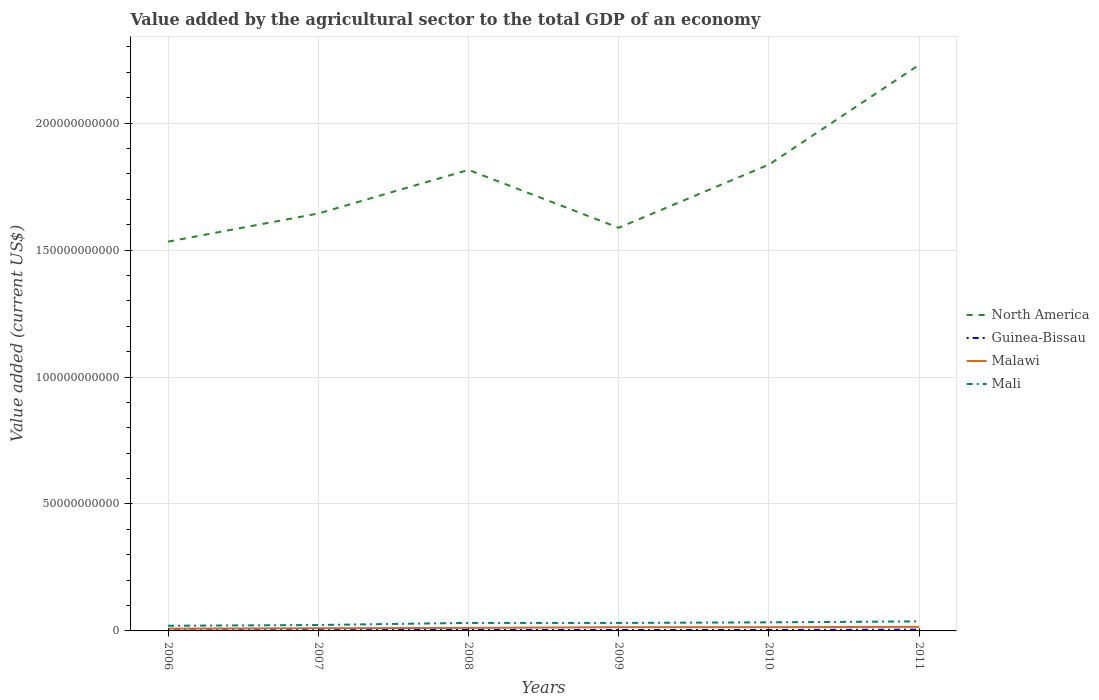Across all years, what is the maximum value added by the agricultural sector to the total GDP in Malawi?
Give a very brief answer. 8.95e+08. What is the total value added by the agricultural sector to the total GDP in North America in the graph?
Your response must be concise. -2.08e+09. What is the difference between the highest and the second highest value added by the agricultural sector to the total GDP in Mali?
Your response must be concise. 1.72e+09. What is the difference between the highest and the lowest value added by the agricultural sector to the total GDP in North America?
Offer a very short reply. 3. Is the value added by the agricultural sector to the total GDP in Malawi strictly greater than the value added by the agricultural sector to the total GDP in Mali over the years?
Your response must be concise. Yes. How many lines are there?
Provide a short and direct response. 4. What is the difference between two consecutive major ticks on the Y-axis?
Provide a short and direct response. 5.00e+1. Are the values on the major ticks of Y-axis written in scientific E-notation?
Your answer should be compact. No. Does the graph contain any zero values?
Make the answer very short. No. Does the graph contain grids?
Give a very brief answer. Yes. Where does the legend appear in the graph?
Ensure brevity in your answer.  Center right. How are the legend labels stacked?
Your answer should be very brief. Vertical. What is the title of the graph?
Offer a terse response. Value added by the agricultural sector to the total GDP of an economy. What is the label or title of the Y-axis?
Ensure brevity in your answer.  Value added (current US$). What is the Value added (current US$) of North America in 2006?
Your answer should be compact. 1.53e+11. What is the Value added (current US$) of Guinea-Bissau in 2006?
Offer a very short reply. 2.48e+08. What is the Value added (current US$) in Malawi in 2006?
Provide a short and direct response. 8.95e+08. What is the Value added (current US$) in Mali in 2006?
Offer a terse response. 2.03e+09. What is the Value added (current US$) in North America in 2007?
Provide a short and direct response. 1.64e+11. What is the Value added (current US$) in Guinea-Bissau in 2007?
Provide a short and direct response. 2.98e+08. What is the Value added (current US$) in Malawi in 2007?
Your response must be concise. 1.06e+09. What is the Value added (current US$) in Mali in 2007?
Make the answer very short. 2.33e+09. What is the Value added (current US$) in North America in 2008?
Your answer should be very brief. 1.82e+11. What is the Value added (current US$) in Guinea-Bissau in 2008?
Give a very brief answer. 4.01e+08. What is the Value added (current US$) of Malawi in 2008?
Your response must be concise. 1.19e+09. What is the Value added (current US$) of Mali in 2008?
Offer a very short reply. 3.15e+09. What is the Value added (current US$) of North America in 2009?
Your answer should be compact. 1.59e+11. What is the Value added (current US$) in Guinea-Bissau in 2009?
Make the answer very short. 3.61e+08. What is the Value added (current US$) in Malawi in 2009?
Keep it short and to the point. 1.47e+09. What is the Value added (current US$) of Mali in 2009?
Your answer should be compact. 3.15e+09. What is the Value added (current US$) of North America in 2010?
Your response must be concise. 1.84e+11. What is the Value added (current US$) in Guinea-Bissau in 2010?
Make the answer very short. 3.80e+08. What is the Value added (current US$) of Malawi in 2010?
Keep it short and to the point. 1.48e+09. What is the Value added (current US$) of Mali in 2010?
Provide a succinct answer. 3.38e+09. What is the Value added (current US$) in North America in 2011?
Keep it short and to the point. 2.23e+11. What is the Value added (current US$) in Guinea-Bissau in 2011?
Provide a succinct answer. 4.91e+08. What is the Value added (current US$) in Malawi in 2011?
Your answer should be compact. 1.60e+09. What is the Value added (current US$) in Mali in 2011?
Offer a terse response. 3.76e+09. Across all years, what is the maximum Value added (current US$) in North America?
Provide a short and direct response. 2.23e+11. Across all years, what is the maximum Value added (current US$) of Guinea-Bissau?
Offer a very short reply. 4.91e+08. Across all years, what is the maximum Value added (current US$) of Malawi?
Your answer should be very brief. 1.60e+09. Across all years, what is the maximum Value added (current US$) in Mali?
Provide a succinct answer. 3.76e+09. Across all years, what is the minimum Value added (current US$) of North America?
Offer a very short reply. 1.53e+11. Across all years, what is the minimum Value added (current US$) in Guinea-Bissau?
Offer a very short reply. 2.48e+08. Across all years, what is the minimum Value added (current US$) of Malawi?
Your answer should be very brief. 8.95e+08. Across all years, what is the minimum Value added (current US$) in Mali?
Your answer should be compact. 2.03e+09. What is the total Value added (current US$) of North America in the graph?
Provide a succinct answer. 1.06e+12. What is the total Value added (current US$) of Guinea-Bissau in the graph?
Ensure brevity in your answer.  2.18e+09. What is the total Value added (current US$) in Malawi in the graph?
Your answer should be very brief. 7.70e+09. What is the total Value added (current US$) of Mali in the graph?
Your response must be concise. 1.78e+1. What is the difference between the Value added (current US$) of North America in 2006 and that in 2007?
Your response must be concise. -1.11e+1. What is the difference between the Value added (current US$) in Guinea-Bissau in 2006 and that in 2007?
Keep it short and to the point. -5.02e+07. What is the difference between the Value added (current US$) in Malawi in 2006 and that in 2007?
Provide a succinct answer. -1.62e+08. What is the difference between the Value added (current US$) of Mali in 2006 and that in 2007?
Give a very brief answer. -2.92e+08. What is the difference between the Value added (current US$) in North America in 2006 and that in 2008?
Your response must be concise. -2.82e+1. What is the difference between the Value added (current US$) of Guinea-Bissau in 2006 and that in 2008?
Your answer should be compact. -1.53e+08. What is the difference between the Value added (current US$) in Malawi in 2006 and that in 2008?
Offer a very short reply. -2.99e+08. What is the difference between the Value added (current US$) in Mali in 2006 and that in 2008?
Offer a terse response. -1.12e+09. What is the difference between the Value added (current US$) of North America in 2006 and that in 2009?
Keep it short and to the point. -5.45e+09. What is the difference between the Value added (current US$) of Guinea-Bissau in 2006 and that in 2009?
Your answer should be very brief. -1.13e+08. What is the difference between the Value added (current US$) in Malawi in 2006 and that in 2009?
Your answer should be very brief. -5.74e+08. What is the difference between the Value added (current US$) of Mali in 2006 and that in 2009?
Your answer should be very brief. -1.11e+09. What is the difference between the Value added (current US$) in North America in 2006 and that in 2010?
Offer a very short reply. -3.03e+1. What is the difference between the Value added (current US$) in Guinea-Bissau in 2006 and that in 2010?
Your answer should be very brief. -1.32e+08. What is the difference between the Value added (current US$) in Malawi in 2006 and that in 2010?
Your response must be concise. -5.88e+08. What is the difference between the Value added (current US$) in Mali in 2006 and that in 2010?
Offer a terse response. -1.34e+09. What is the difference between the Value added (current US$) of North America in 2006 and that in 2011?
Your answer should be very brief. -6.96e+1. What is the difference between the Value added (current US$) in Guinea-Bissau in 2006 and that in 2011?
Your answer should be very brief. -2.43e+08. What is the difference between the Value added (current US$) in Malawi in 2006 and that in 2011?
Give a very brief answer. -7.08e+08. What is the difference between the Value added (current US$) in Mali in 2006 and that in 2011?
Give a very brief answer. -1.72e+09. What is the difference between the Value added (current US$) in North America in 2007 and that in 2008?
Your response must be concise. -1.72e+1. What is the difference between the Value added (current US$) of Guinea-Bissau in 2007 and that in 2008?
Keep it short and to the point. -1.02e+08. What is the difference between the Value added (current US$) in Malawi in 2007 and that in 2008?
Ensure brevity in your answer.  -1.37e+08. What is the difference between the Value added (current US$) of Mali in 2007 and that in 2008?
Offer a very short reply. -8.28e+08. What is the difference between the Value added (current US$) in North America in 2007 and that in 2009?
Offer a terse response. 5.62e+09. What is the difference between the Value added (current US$) in Guinea-Bissau in 2007 and that in 2009?
Your response must be concise. -6.27e+07. What is the difference between the Value added (current US$) in Malawi in 2007 and that in 2009?
Provide a short and direct response. -4.12e+08. What is the difference between the Value added (current US$) of Mali in 2007 and that in 2009?
Offer a very short reply. -8.22e+08. What is the difference between the Value added (current US$) in North America in 2007 and that in 2010?
Provide a succinct answer. -1.93e+1. What is the difference between the Value added (current US$) in Guinea-Bissau in 2007 and that in 2010?
Your answer should be compact. -8.20e+07. What is the difference between the Value added (current US$) in Malawi in 2007 and that in 2010?
Offer a very short reply. -4.26e+08. What is the difference between the Value added (current US$) of Mali in 2007 and that in 2010?
Offer a terse response. -1.05e+09. What is the difference between the Value added (current US$) in North America in 2007 and that in 2011?
Offer a terse response. -5.85e+1. What is the difference between the Value added (current US$) of Guinea-Bissau in 2007 and that in 2011?
Provide a succinct answer. -1.93e+08. What is the difference between the Value added (current US$) in Malawi in 2007 and that in 2011?
Provide a succinct answer. -5.46e+08. What is the difference between the Value added (current US$) of Mali in 2007 and that in 2011?
Your answer should be very brief. -1.43e+09. What is the difference between the Value added (current US$) in North America in 2008 and that in 2009?
Ensure brevity in your answer.  2.28e+1. What is the difference between the Value added (current US$) of Guinea-Bissau in 2008 and that in 2009?
Your answer should be compact. 3.97e+07. What is the difference between the Value added (current US$) of Malawi in 2008 and that in 2009?
Offer a very short reply. -2.75e+08. What is the difference between the Value added (current US$) of Mali in 2008 and that in 2009?
Keep it short and to the point. 5.58e+06. What is the difference between the Value added (current US$) in North America in 2008 and that in 2010?
Provide a short and direct response. -2.08e+09. What is the difference between the Value added (current US$) of Guinea-Bissau in 2008 and that in 2010?
Provide a short and direct response. 2.05e+07. What is the difference between the Value added (current US$) in Malawi in 2008 and that in 2010?
Your answer should be compact. -2.88e+08. What is the difference between the Value added (current US$) in Mali in 2008 and that in 2010?
Offer a terse response. -2.24e+08. What is the difference between the Value added (current US$) in North America in 2008 and that in 2011?
Your answer should be very brief. -4.14e+1. What is the difference between the Value added (current US$) of Guinea-Bissau in 2008 and that in 2011?
Provide a succinct answer. -9.05e+07. What is the difference between the Value added (current US$) in Malawi in 2008 and that in 2011?
Offer a very short reply. -4.09e+08. What is the difference between the Value added (current US$) in Mali in 2008 and that in 2011?
Give a very brief answer. -6.04e+08. What is the difference between the Value added (current US$) of North America in 2009 and that in 2010?
Keep it short and to the point. -2.49e+1. What is the difference between the Value added (current US$) in Guinea-Bissau in 2009 and that in 2010?
Ensure brevity in your answer.  -1.93e+07. What is the difference between the Value added (current US$) of Malawi in 2009 and that in 2010?
Offer a terse response. -1.34e+07. What is the difference between the Value added (current US$) of Mali in 2009 and that in 2010?
Your answer should be very brief. -2.30e+08. What is the difference between the Value added (current US$) in North America in 2009 and that in 2011?
Ensure brevity in your answer.  -6.42e+1. What is the difference between the Value added (current US$) of Guinea-Bissau in 2009 and that in 2011?
Your answer should be compact. -1.30e+08. What is the difference between the Value added (current US$) of Malawi in 2009 and that in 2011?
Make the answer very short. -1.34e+08. What is the difference between the Value added (current US$) in Mali in 2009 and that in 2011?
Offer a terse response. -6.10e+08. What is the difference between the Value added (current US$) in North America in 2010 and that in 2011?
Give a very brief answer. -3.93e+1. What is the difference between the Value added (current US$) of Guinea-Bissau in 2010 and that in 2011?
Ensure brevity in your answer.  -1.11e+08. What is the difference between the Value added (current US$) of Malawi in 2010 and that in 2011?
Give a very brief answer. -1.20e+08. What is the difference between the Value added (current US$) of Mali in 2010 and that in 2011?
Your answer should be very brief. -3.80e+08. What is the difference between the Value added (current US$) in North America in 2006 and the Value added (current US$) in Guinea-Bissau in 2007?
Your answer should be compact. 1.53e+11. What is the difference between the Value added (current US$) of North America in 2006 and the Value added (current US$) of Malawi in 2007?
Offer a terse response. 1.52e+11. What is the difference between the Value added (current US$) in North America in 2006 and the Value added (current US$) in Mali in 2007?
Provide a succinct answer. 1.51e+11. What is the difference between the Value added (current US$) in Guinea-Bissau in 2006 and the Value added (current US$) in Malawi in 2007?
Your answer should be compact. -8.09e+08. What is the difference between the Value added (current US$) of Guinea-Bissau in 2006 and the Value added (current US$) of Mali in 2007?
Give a very brief answer. -2.08e+09. What is the difference between the Value added (current US$) in Malawi in 2006 and the Value added (current US$) in Mali in 2007?
Your answer should be very brief. -1.43e+09. What is the difference between the Value added (current US$) in North America in 2006 and the Value added (current US$) in Guinea-Bissau in 2008?
Offer a terse response. 1.53e+11. What is the difference between the Value added (current US$) in North America in 2006 and the Value added (current US$) in Malawi in 2008?
Give a very brief answer. 1.52e+11. What is the difference between the Value added (current US$) in North America in 2006 and the Value added (current US$) in Mali in 2008?
Offer a terse response. 1.50e+11. What is the difference between the Value added (current US$) of Guinea-Bissau in 2006 and the Value added (current US$) of Malawi in 2008?
Provide a succinct answer. -9.47e+08. What is the difference between the Value added (current US$) in Guinea-Bissau in 2006 and the Value added (current US$) in Mali in 2008?
Give a very brief answer. -2.91e+09. What is the difference between the Value added (current US$) in Malawi in 2006 and the Value added (current US$) in Mali in 2008?
Provide a succinct answer. -2.26e+09. What is the difference between the Value added (current US$) in North America in 2006 and the Value added (current US$) in Guinea-Bissau in 2009?
Offer a terse response. 1.53e+11. What is the difference between the Value added (current US$) of North America in 2006 and the Value added (current US$) of Malawi in 2009?
Make the answer very short. 1.52e+11. What is the difference between the Value added (current US$) in North America in 2006 and the Value added (current US$) in Mali in 2009?
Give a very brief answer. 1.50e+11. What is the difference between the Value added (current US$) in Guinea-Bissau in 2006 and the Value added (current US$) in Malawi in 2009?
Provide a succinct answer. -1.22e+09. What is the difference between the Value added (current US$) in Guinea-Bissau in 2006 and the Value added (current US$) in Mali in 2009?
Offer a very short reply. -2.90e+09. What is the difference between the Value added (current US$) in Malawi in 2006 and the Value added (current US$) in Mali in 2009?
Keep it short and to the point. -2.25e+09. What is the difference between the Value added (current US$) of North America in 2006 and the Value added (current US$) of Guinea-Bissau in 2010?
Offer a terse response. 1.53e+11. What is the difference between the Value added (current US$) of North America in 2006 and the Value added (current US$) of Malawi in 2010?
Make the answer very short. 1.52e+11. What is the difference between the Value added (current US$) of North America in 2006 and the Value added (current US$) of Mali in 2010?
Your response must be concise. 1.50e+11. What is the difference between the Value added (current US$) in Guinea-Bissau in 2006 and the Value added (current US$) in Malawi in 2010?
Your answer should be compact. -1.24e+09. What is the difference between the Value added (current US$) in Guinea-Bissau in 2006 and the Value added (current US$) in Mali in 2010?
Your answer should be compact. -3.13e+09. What is the difference between the Value added (current US$) of Malawi in 2006 and the Value added (current US$) of Mali in 2010?
Keep it short and to the point. -2.48e+09. What is the difference between the Value added (current US$) in North America in 2006 and the Value added (current US$) in Guinea-Bissau in 2011?
Provide a succinct answer. 1.53e+11. What is the difference between the Value added (current US$) in North America in 2006 and the Value added (current US$) in Malawi in 2011?
Provide a short and direct response. 1.52e+11. What is the difference between the Value added (current US$) of North America in 2006 and the Value added (current US$) of Mali in 2011?
Provide a succinct answer. 1.50e+11. What is the difference between the Value added (current US$) of Guinea-Bissau in 2006 and the Value added (current US$) of Malawi in 2011?
Make the answer very short. -1.36e+09. What is the difference between the Value added (current US$) in Guinea-Bissau in 2006 and the Value added (current US$) in Mali in 2011?
Provide a short and direct response. -3.51e+09. What is the difference between the Value added (current US$) in Malawi in 2006 and the Value added (current US$) in Mali in 2011?
Offer a very short reply. -2.86e+09. What is the difference between the Value added (current US$) of North America in 2007 and the Value added (current US$) of Guinea-Bissau in 2008?
Ensure brevity in your answer.  1.64e+11. What is the difference between the Value added (current US$) in North America in 2007 and the Value added (current US$) in Malawi in 2008?
Offer a very short reply. 1.63e+11. What is the difference between the Value added (current US$) of North America in 2007 and the Value added (current US$) of Mali in 2008?
Ensure brevity in your answer.  1.61e+11. What is the difference between the Value added (current US$) of Guinea-Bissau in 2007 and the Value added (current US$) of Malawi in 2008?
Offer a very short reply. -8.96e+08. What is the difference between the Value added (current US$) of Guinea-Bissau in 2007 and the Value added (current US$) of Mali in 2008?
Offer a very short reply. -2.86e+09. What is the difference between the Value added (current US$) of Malawi in 2007 and the Value added (current US$) of Mali in 2008?
Ensure brevity in your answer.  -2.10e+09. What is the difference between the Value added (current US$) of North America in 2007 and the Value added (current US$) of Guinea-Bissau in 2009?
Offer a very short reply. 1.64e+11. What is the difference between the Value added (current US$) of North America in 2007 and the Value added (current US$) of Malawi in 2009?
Provide a short and direct response. 1.63e+11. What is the difference between the Value added (current US$) of North America in 2007 and the Value added (current US$) of Mali in 2009?
Provide a succinct answer. 1.61e+11. What is the difference between the Value added (current US$) of Guinea-Bissau in 2007 and the Value added (current US$) of Malawi in 2009?
Offer a very short reply. -1.17e+09. What is the difference between the Value added (current US$) of Guinea-Bissau in 2007 and the Value added (current US$) of Mali in 2009?
Provide a succinct answer. -2.85e+09. What is the difference between the Value added (current US$) in Malawi in 2007 and the Value added (current US$) in Mali in 2009?
Your response must be concise. -2.09e+09. What is the difference between the Value added (current US$) of North America in 2007 and the Value added (current US$) of Guinea-Bissau in 2010?
Provide a short and direct response. 1.64e+11. What is the difference between the Value added (current US$) in North America in 2007 and the Value added (current US$) in Malawi in 2010?
Your response must be concise. 1.63e+11. What is the difference between the Value added (current US$) of North America in 2007 and the Value added (current US$) of Mali in 2010?
Your answer should be compact. 1.61e+11. What is the difference between the Value added (current US$) in Guinea-Bissau in 2007 and the Value added (current US$) in Malawi in 2010?
Your response must be concise. -1.18e+09. What is the difference between the Value added (current US$) of Guinea-Bissau in 2007 and the Value added (current US$) of Mali in 2010?
Offer a very short reply. -3.08e+09. What is the difference between the Value added (current US$) in Malawi in 2007 and the Value added (current US$) in Mali in 2010?
Your response must be concise. -2.32e+09. What is the difference between the Value added (current US$) of North America in 2007 and the Value added (current US$) of Guinea-Bissau in 2011?
Your response must be concise. 1.64e+11. What is the difference between the Value added (current US$) in North America in 2007 and the Value added (current US$) in Malawi in 2011?
Provide a short and direct response. 1.63e+11. What is the difference between the Value added (current US$) in North America in 2007 and the Value added (current US$) in Mali in 2011?
Your answer should be very brief. 1.61e+11. What is the difference between the Value added (current US$) in Guinea-Bissau in 2007 and the Value added (current US$) in Malawi in 2011?
Offer a terse response. -1.31e+09. What is the difference between the Value added (current US$) of Guinea-Bissau in 2007 and the Value added (current US$) of Mali in 2011?
Offer a very short reply. -3.46e+09. What is the difference between the Value added (current US$) of Malawi in 2007 and the Value added (current US$) of Mali in 2011?
Your answer should be compact. -2.70e+09. What is the difference between the Value added (current US$) in North America in 2008 and the Value added (current US$) in Guinea-Bissau in 2009?
Offer a very short reply. 1.81e+11. What is the difference between the Value added (current US$) in North America in 2008 and the Value added (current US$) in Malawi in 2009?
Provide a short and direct response. 1.80e+11. What is the difference between the Value added (current US$) of North America in 2008 and the Value added (current US$) of Mali in 2009?
Make the answer very short. 1.78e+11. What is the difference between the Value added (current US$) of Guinea-Bissau in 2008 and the Value added (current US$) of Malawi in 2009?
Your answer should be very brief. -1.07e+09. What is the difference between the Value added (current US$) in Guinea-Bissau in 2008 and the Value added (current US$) in Mali in 2009?
Provide a short and direct response. -2.75e+09. What is the difference between the Value added (current US$) of Malawi in 2008 and the Value added (current US$) of Mali in 2009?
Keep it short and to the point. -1.95e+09. What is the difference between the Value added (current US$) of North America in 2008 and the Value added (current US$) of Guinea-Bissau in 2010?
Offer a terse response. 1.81e+11. What is the difference between the Value added (current US$) of North America in 2008 and the Value added (current US$) of Malawi in 2010?
Your response must be concise. 1.80e+11. What is the difference between the Value added (current US$) of North America in 2008 and the Value added (current US$) of Mali in 2010?
Provide a succinct answer. 1.78e+11. What is the difference between the Value added (current US$) of Guinea-Bissau in 2008 and the Value added (current US$) of Malawi in 2010?
Your answer should be very brief. -1.08e+09. What is the difference between the Value added (current US$) in Guinea-Bissau in 2008 and the Value added (current US$) in Mali in 2010?
Make the answer very short. -2.98e+09. What is the difference between the Value added (current US$) of Malawi in 2008 and the Value added (current US$) of Mali in 2010?
Give a very brief answer. -2.18e+09. What is the difference between the Value added (current US$) in North America in 2008 and the Value added (current US$) in Guinea-Bissau in 2011?
Keep it short and to the point. 1.81e+11. What is the difference between the Value added (current US$) of North America in 2008 and the Value added (current US$) of Malawi in 2011?
Offer a terse response. 1.80e+11. What is the difference between the Value added (current US$) in North America in 2008 and the Value added (current US$) in Mali in 2011?
Your answer should be very brief. 1.78e+11. What is the difference between the Value added (current US$) in Guinea-Bissau in 2008 and the Value added (current US$) in Malawi in 2011?
Make the answer very short. -1.20e+09. What is the difference between the Value added (current US$) of Guinea-Bissau in 2008 and the Value added (current US$) of Mali in 2011?
Keep it short and to the point. -3.36e+09. What is the difference between the Value added (current US$) of Malawi in 2008 and the Value added (current US$) of Mali in 2011?
Your answer should be very brief. -2.56e+09. What is the difference between the Value added (current US$) of North America in 2009 and the Value added (current US$) of Guinea-Bissau in 2010?
Offer a very short reply. 1.58e+11. What is the difference between the Value added (current US$) of North America in 2009 and the Value added (current US$) of Malawi in 2010?
Your answer should be very brief. 1.57e+11. What is the difference between the Value added (current US$) of North America in 2009 and the Value added (current US$) of Mali in 2010?
Keep it short and to the point. 1.55e+11. What is the difference between the Value added (current US$) of Guinea-Bissau in 2009 and the Value added (current US$) of Malawi in 2010?
Keep it short and to the point. -1.12e+09. What is the difference between the Value added (current US$) of Guinea-Bissau in 2009 and the Value added (current US$) of Mali in 2010?
Your answer should be very brief. -3.02e+09. What is the difference between the Value added (current US$) in Malawi in 2009 and the Value added (current US$) in Mali in 2010?
Make the answer very short. -1.91e+09. What is the difference between the Value added (current US$) in North America in 2009 and the Value added (current US$) in Guinea-Bissau in 2011?
Your response must be concise. 1.58e+11. What is the difference between the Value added (current US$) of North America in 2009 and the Value added (current US$) of Malawi in 2011?
Your response must be concise. 1.57e+11. What is the difference between the Value added (current US$) in North America in 2009 and the Value added (current US$) in Mali in 2011?
Keep it short and to the point. 1.55e+11. What is the difference between the Value added (current US$) of Guinea-Bissau in 2009 and the Value added (current US$) of Malawi in 2011?
Make the answer very short. -1.24e+09. What is the difference between the Value added (current US$) of Guinea-Bissau in 2009 and the Value added (current US$) of Mali in 2011?
Offer a very short reply. -3.40e+09. What is the difference between the Value added (current US$) of Malawi in 2009 and the Value added (current US$) of Mali in 2011?
Ensure brevity in your answer.  -2.29e+09. What is the difference between the Value added (current US$) in North America in 2010 and the Value added (current US$) in Guinea-Bissau in 2011?
Provide a short and direct response. 1.83e+11. What is the difference between the Value added (current US$) in North America in 2010 and the Value added (current US$) in Malawi in 2011?
Provide a short and direct response. 1.82e+11. What is the difference between the Value added (current US$) of North America in 2010 and the Value added (current US$) of Mali in 2011?
Provide a short and direct response. 1.80e+11. What is the difference between the Value added (current US$) in Guinea-Bissau in 2010 and the Value added (current US$) in Malawi in 2011?
Give a very brief answer. -1.22e+09. What is the difference between the Value added (current US$) in Guinea-Bissau in 2010 and the Value added (current US$) in Mali in 2011?
Give a very brief answer. -3.38e+09. What is the difference between the Value added (current US$) of Malawi in 2010 and the Value added (current US$) of Mali in 2011?
Your answer should be very brief. -2.27e+09. What is the average Value added (current US$) of North America per year?
Your response must be concise. 1.77e+11. What is the average Value added (current US$) in Guinea-Bissau per year?
Your response must be concise. 3.63e+08. What is the average Value added (current US$) of Malawi per year?
Your answer should be compact. 1.28e+09. What is the average Value added (current US$) in Mali per year?
Your answer should be very brief. 2.97e+09. In the year 2006, what is the difference between the Value added (current US$) in North America and Value added (current US$) in Guinea-Bissau?
Provide a succinct answer. 1.53e+11. In the year 2006, what is the difference between the Value added (current US$) in North America and Value added (current US$) in Malawi?
Your answer should be very brief. 1.52e+11. In the year 2006, what is the difference between the Value added (current US$) in North America and Value added (current US$) in Mali?
Offer a very short reply. 1.51e+11. In the year 2006, what is the difference between the Value added (current US$) in Guinea-Bissau and Value added (current US$) in Malawi?
Give a very brief answer. -6.47e+08. In the year 2006, what is the difference between the Value added (current US$) in Guinea-Bissau and Value added (current US$) in Mali?
Offer a very short reply. -1.79e+09. In the year 2006, what is the difference between the Value added (current US$) in Malawi and Value added (current US$) in Mali?
Your answer should be compact. -1.14e+09. In the year 2007, what is the difference between the Value added (current US$) in North America and Value added (current US$) in Guinea-Bissau?
Ensure brevity in your answer.  1.64e+11. In the year 2007, what is the difference between the Value added (current US$) in North America and Value added (current US$) in Malawi?
Your response must be concise. 1.63e+11. In the year 2007, what is the difference between the Value added (current US$) in North America and Value added (current US$) in Mali?
Make the answer very short. 1.62e+11. In the year 2007, what is the difference between the Value added (current US$) in Guinea-Bissau and Value added (current US$) in Malawi?
Provide a short and direct response. -7.59e+08. In the year 2007, what is the difference between the Value added (current US$) in Guinea-Bissau and Value added (current US$) in Mali?
Offer a very short reply. -2.03e+09. In the year 2007, what is the difference between the Value added (current US$) of Malawi and Value added (current US$) of Mali?
Make the answer very short. -1.27e+09. In the year 2008, what is the difference between the Value added (current US$) in North America and Value added (current US$) in Guinea-Bissau?
Your answer should be very brief. 1.81e+11. In the year 2008, what is the difference between the Value added (current US$) in North America and Value added (current US$) in Malawi?
Offer a very short reply. 1.80e+11. In the year 2008, what is the difference between the Value added (current US$) in North America and Value added (current US$) in Mali?
Keep it short and to the point. 1.78e+11. In the year 2008, what is the difference between the Value added (current US$) in Guinea-Bissau and Value added (current US$) in Malawi?
Provide a short and direct response. -7.94e+08. In the year 2008, what is the difference between the Value added (current US$) of Guinea-Bissau and Value added (current US$) of Mali?
Your response must be concise. -2.75e+09. In the year 2008, what is the difference between the Value added (current US$) of Malawi and Value added (current US$) of Mali?
Your response must be concise. -1.96e+09. In the year 2009, what is the difference between the Value added (current US$) in North America and Value added (current US$) in Guinea-Bissau?
Offer a very short reply. 1.58e+11. In the year 2009, what is the difference between the Value added (current US$) in North America and Value added (current US$) in Malawi?
Provide a succinct answer. 1.57e+11. In the year 2009, what is the difference between the Value added (current US$) in North America and Value added (current US$) in Mali?
Provide a short and direct response. 1.56e+11. In the year 2009, what is the difference between the Value added (current US$) in Guinea-Bissau and Value added (current US$) in Malawi?
Give a very brief answer. -1.11e+09. In the year 2009, what is the difference between the Value added (current US$) of Guinea-Bissau and Value added (current US$) of Mali?
Ensure brevity in your answer.  -2.79e+09. In the year 2009, what is the difference between the Value added (current US$) of Malawi and Value added (current US$) of Mali?
Your response must be concise. -1.68e+09. In the year 2010, what is the difference between the Value added (current US$) of North America and Value added (current US$) of Guinea-Bissau?
Your answer should be very brief. 1.83e+11. In the year 2010, what is the difference between the Value added (current US$) of North America and Value added (current US$) of Malawi?
Your answer should be compact. 1.82e+11. In the year 2010, what is the difference between the Value added (current US$) of North America and Value added (current US$) of Mali?
Offer a very short reply. 1.80e+11. In the year 2010, what is the difference between the Value added (current US$) of Guinea-Bissau and Value added (current US$) of Malawi?
Offer a very short reply. -1.10e+09. In the year 2010, what is the difference between the Value added (current US$) in Guinea-Bissau and Value added (current US$) in Mali?
Keep it short and to the point. -3.00e+09. In the year 2010, what is the difference between the Value added (current US$) of Malawi and Value added (current US$) of Mali?
Your response must be concise. -1.89e+09. In the year 2011, what is the difference between the Value added (current US$) of North America and Value added (current US$) of Guinea-Bissau?
Offer a very short reply. 2.22e+11. In the year 2011, what is the difference between the Value added (current US$) of North America and Value added (current US$) of Malawi?
Make the answer very short. 2.21e+11. In the year 2011, what is the difference between the Value added (current US$) of North America and Value added (current US$) of Mali?
Your answer should be very brief. 2.19e+11. In the year 2011, what is the difference between the Value added (current US$) of Guinea-Bissau and Value added (current US$) of Malawi?
Provide a short and direct response. -1.11e+09. In the year 2011, what is the difference between the Value added (current US$) in Guinea-Bissau and Value added (current US$) in Mali?
Offer a very short reply. -3.27e+09. In the year 2011, what is the difference between the Value added (current US$) of Malawi and Value added (current US$) of Mali?
Keep it short and to the point. -2.15e+09. What is the ratio of the Value added (current US$) of North America in 2006 to that in 2007?
Give a very brief answer. 0.93. What is the ratio of the Value added (current US$) in Guinea-Bissau in 2006 to that in 2007?
Provide a succinct answer. 0.83. What is the ratio of the Value added (current US$) in Malawi in 2006 to that in 2007?
Ensure brevity in your answer.  0.85. What is the ratio of the Value added (current US$) of Mali in 2006 to that in 2007?
Ensure brevity in your answer.  0.87. What is the ratio of the Value added (current US$) of North America in 2006 to that in 2008?
Your answer should be very brief. 0.84. What is the ratio of the Value added (current US$) in Guinea-Bissau in 2006 to that in 2008?
Make the answer very short. 0.62. What is the ratio of the Value added (current US$) of Malawi in 2006 to that in 2008?
Your answer should be compact. 0.75. What is the ratio of the Value added (current US$) of Mali in 2006 to that in 2008?
Provide a short and direct response. 0.65. What is the ratio of the Value added (current US$) of North America in 2006 to that in 2009?
Your response must be concise. 0.97. What is the ratio of the Value added (current US$) in Guinea-Bissau in 2006 to that in 2009?
Give a very brief answer. 0.69. What is the ratio of the Value added (current US$) in Malawi in 2006 to that in 2009?
Your response must be concise. 0.61. What is the ratio of the Value added (current US$) in Mali in 2006 to that in 2009?
Your response must be concise. 0.65. What is the ratio of the Value added (current US$) of North America in 2006 to that in 2010?
Give a very brief answer. 0.83. What is the ratio of the Value added (current US$) of Guinea-Bissau in 2006 to that in 2010?
Offer a very short reply. 0.65. What is the ratio of the Value added (current US$) in Malawi in 2006 to that in 2010?
Your answer should be very brief. 0.6. What is the ratio of the Value added (current US$) in Mali in 2006 to that in 2010?
Provide a succinct answer. 0.6. What is the ratio of the Value added (current US$) of North America in 2006 to that in 2011?
Make the answer very short. 0.69. What is the ratio of the Value added (current US$) of Guinea-Bissau in 2006 to that in 2011?
Offer a very short reply. 0.5. What is the ratio of the Value added (current US$) in Malawi in 2006 to that in 2011?
Ensure brevity in your answer.  0.56. What is the ratio of the Value added (current US$) in Mali in 2006 to that in 2011?
Your answer should be very brief. 0.54. What is the ratio of the Value added (current US$) in North America in 2007 to that in 2008?
Offer a terse response. 0.91. What is the ratio of the Value added (current US$) of Guinea-Bissau in 2007 to that in 2008?
Offer a very short reply. 0.74. What is the ratio of the Value added (current US$) in Malawi in 2007 to that in 2008?
Your answer should be compact. 0.89. What is the ratio of the Value added (current US$) in Mali in 2007 to that in 2008?
Keep it short and to the point. 0.74. What is the ratio of the Value added (current US$) in North America in 2007 to that in 2009?
Your answer should be very brief. 1.04. What is the ratio of the Value added (current US$) in Guinea-Bissau in 2007 to that in 2009?
Offer a terse response. 0.83. What is the ratio of the Value added (current US$) of Malawi in 2007 to that in 2009?
Provide a succinct answer. 0.72. What is the ratio of the Value added (current US$) of Mali in 2007 to that in 2009?
Offer a terse response. 0.74. What is the ratio of the Value added (current US$) of North America in 2007 to that in 2010?
Keep it short and to the point. 0.9. What is the ratio of the Value added (current US$) in Guinea-Bissau in 2007 to that in 2010?
Your response must be concise. 0.78. What is the ratio of the Value added (current US$) of Malawi in 2007 to that in 2010?
Your answer should be very brief. 0.71. What is the ratio of the Value added (current US$) of Mali in 2007 to that in 2010?
Provide a short and direct response. 0.69. What is the ratio of the Value added (current US$) in North America in 2007 to that in 2011?
Ensure brevity in your answer.  0.74. What is the ratio of the Value added (current US$) in Guinea-Bissau in 2007 to that in 2011?
Keep it short and to the point. 0.61. What is the ratio of the Value added (current US$) in Malawi in 2007 to that in 2011?
Make the answer very short. 0.66. What is the ratio of the Value added (current US$) in Mali in 2007 to that in 2011?
Offer a terse response. 0.62. What is the ratio of the Value added (current US$) in North America in 2008 to that in 2009?
Your answer should be very brief. 1.14. What is the ratio of the Value added (current US$) in Guinea-Bissau in 2008 to that in 2009?
Your response must be concise. 1.11. What is the ratio of the Value added (current US$) in Malawi in 2008 to that in 2009?
Ensure brevity in your answer.  0.81. What is the ratio of the Value added (current US$) of Mali in 2008 to that in 2009?
Your response must be concise. 1. What is the ratio of the Value added (current US$) in North America in 2008 to that in 2010?
Make the answer very short. 0.99. What is the ratio of the Value added (current US$) of Guinea-Bissau in 2008 to that in 2010?
Give a very brief answer. 1.05. What is the ratio of the Value added (current US$) of Malawi in 2008 to that in 2010?
Keep it short and to the point. 0.81. What is the ratio of the Value added (current US$) in Mali in 2008 to that in 2010?
Your response must be concise. 0.93. What is the ratio of the Value added (current US$) in North America in 2008 to that in 2011?
Your answer should be compact. 0.81. What is the ratio of the Value added (current US$) of Guinea-Bissau in 2008 to that in 2011?
Provide a succinct answer. 0.82. What is the ratio of the Value added (current US$) of Malawi in 2008 to that in 2011?
Give a very brief answer. 0.74. What is the ratio of the Value added (current US$) of Mali in 2008 to that in 2011?
Your answer should be very brief. 0.84. What is the ratio of the Value added (current US$) in North America in 2009 to that in 2010?
Your answer should be very brief. 0.86. What is the ratio of the Value added (current US$) of Guinea-Bissau in 2009 to that in 2010?
Keep it short and to the point. 0.95. What is the ratio of the Value added (current US$) in Mali in 2009 to that in 2010?
Ensure brevity in your answer.  0.93. What is the ratio of the Value added (current US$) of North America in 2009 to that in 2011?
Keep it short and to the point. 0.71. What is the ratio of the Value added (current US$) in Guinea-Bissau in 2009 to that in 2011?
Ensure brevity in your answer.  0.73. What is the ratio of the Value added (current US$) in Malawi in 2009 to that in 2011?
Provide a succinct answer. 0.92. What is the ratio of the Value added (current US$) of Mali in 2009 to that in 2011?
Make the answer very short. 0.84. What is the ratio of the Value added (current US$) in North America in 2010 to that in 2011?
Give a very brief answer. 0.82. What is the ratio of the Value added (current US$) in Guinea-Bissau in 2010 to that in 2011?
Your response must be concise. 0.77. What is the ratio of the Value added (current US$) in Malawi in 2010 to that in 2011?
Keep it short and to the point. 0.92. What is the ratio of the Value added (current US$) of Mali in 2010 to that in 2011?
Give a very brief answer. 0.9. What is the difference between the highest and the second highest Value added (current US$) of North America?
Your answer should be compact. 3.93e+1. What is the difference between the highest and the second highest Value added (current US$) of Guinea-Bissau?
Ensure brevity in your answer.  9.05e+07. What is the difference between the highest and the second highest Value added (current US$) of Malawi?
Give a very brief answer. 1.20e+08. What is the difference between the highest and the second highest Value added (current US$) in Mali?
Keep it short and to the point. 3.80e+08. What is the difference between the highest and the lowest Value added (current US$) of North America?
Keep it short and to the point. 6.96e+1. What is the difference between the highest and the lowest Value added (current US$) of Guinea-Bissau?
Provide a succinct answer. 2.43e+08. What is the difference between the highest and the lowest Value added (current US$) in Malawi?
Provide a short and direct response. 7.08e+08. What is the difference between the highest and the lowest Value added (current US$) of Mali?
Provide a succinct answer. 1.72e+09. 